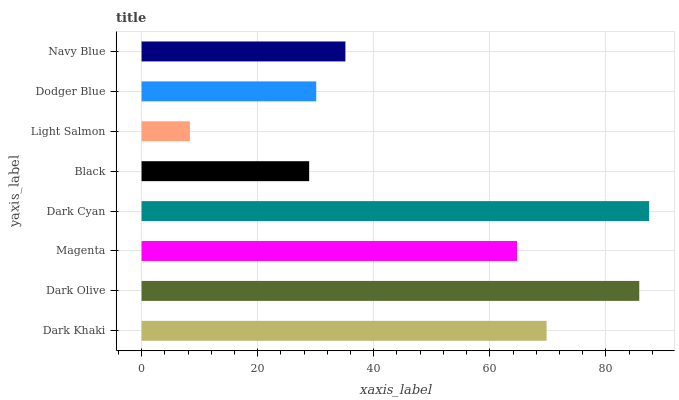Is Light Salmon the minimum?
Answer yes or no. Yes. Is Dark Cyan the maximum?
Answer yes or no. Yes. Is Dark Olive the minimum?
Answer yes or no. No. Is Dark Olive the maximum?
Answer yes or no. No. Is Dark Olive greater than Dark Khaki?
Answer yes or no. Yes. Is Dark Khaki less than Dark Olive?
Answer yes or no. Yes. Is Dark Khaki greater than Dark Olive?
Answer yes or no. No. Is Dark Olive less than Dark Khaki?
Answer yes or no. No. Is Magenta the high median?
Answer yes or no. Yes. Is Navy Blue the low median?
Answer yes or no. Yes. Is Dark Cyan the high median?
Answer yes or no. No. Is Dark Olive the low median?
Answer yes or no. No. 